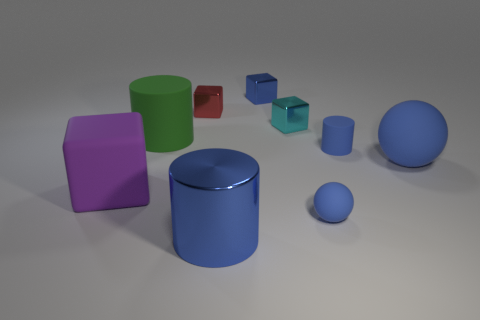Subtract 1 cubes. How many cubes are left? 3 Subtract all blue blocks. Subtract all yellow cylinders. How many blocks are left? 3 Add 1 small yellow cylinders. How many objects exist? 10 Subtract all balls. How many objects are left? 7 Subtract all tiny metallic cubes. Subtract all cyan things. How many objects are left? 5 Add 3 big blue balls. How many big blue balls are left? 4 Add 3 metallic blocks. How many metallic blocks exist? 6 Subtract 2 blue balls. How many objects are left? 7 